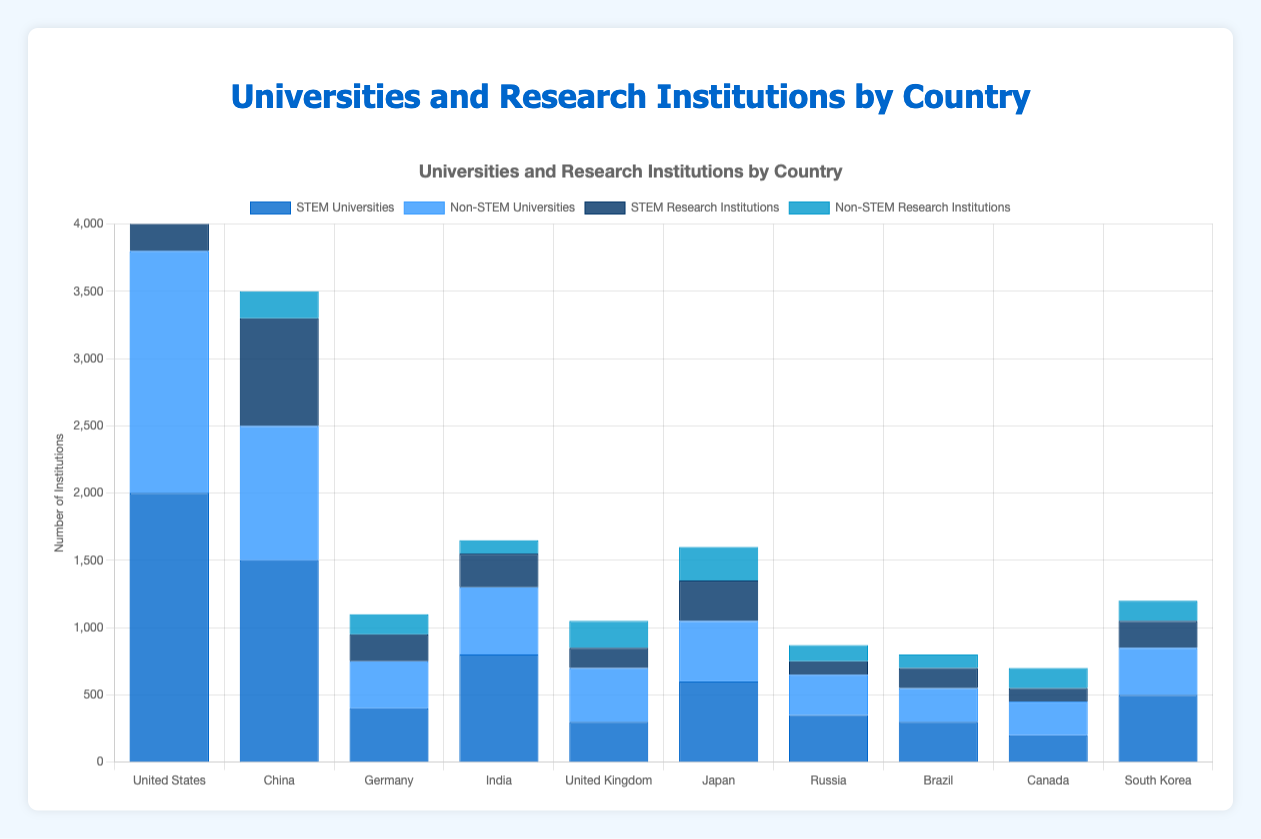Which country has the most STEM universities? By observing the height of the blue bars labeled "STEM Universities," it is evident that the United States has the tallest bar.
Answer: United States How many total institutions (universities and research institutions) does China have for both STEM and Non-STEM fields? Sum the values for universities and research institutions in both fields: (1500 + 1000 + 800 + 200) = 3500.
Answer: 3500 Which country has the least Non-STEM research institutions? By observing the height of the dark blue bars labeled "Non-STEM Research Institutions," Russia has the lowest bar.
Answer: Russia What is the difference between the STEM and Non-STEM universities in Germany? Subtract the number of Non-STEM universities from the number of STEM universities in Germany: 400 - 350 = 50.
Answer: 50 Compare the total number of institutions in India and Brazil. Which country has more? Sum the values for both universities and research institutions in both fields for each country: India = (800 + 500 + 250 + 100) = 1650, Brazil = (300 + 250 + 150 + 100) = 800. India has more institutions.
Answer: India How many more STEM research institutions does China have compared to the United States? Subtract the number of STEM research institutions in the United States from the number in China: 800 - 600 = 200.
Answer: 200 What is the total number of STEM institutions (universities and research institutions) in Japan? Sum the values of STEM universities and STEM research institutions: 600 + 300 = 900.
Answer: 900 Which country has a greater number of Non-STEM universities, Canada or the United Kingdom? By comparing the heights of the bars labeled "Non-STEM Universities" for Canada and the United Kingdom, the United Kingdom has more Non-STEM universities.
Answer: United Kingdom Compare the total number of universities between Russia and South Korea. Sum the values for both STEM and Non-STEM universities for each country: Russia = 350 + 300 = 650, South Korea = 500 + 350 = 850. South Korea has more universities.
Answer: South Korea 